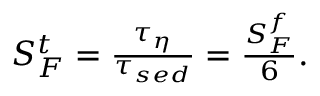<formula> <loc_0><loc_0><loc_500><loc_500>\begin{array} { r } { S _ { F } ^ { t } = \frac { \tau _ { \eta } } { \tau _ { s e d } } = \frac { S _ { F } ^ { f } } { 6 } . } \end{array}</formula> 